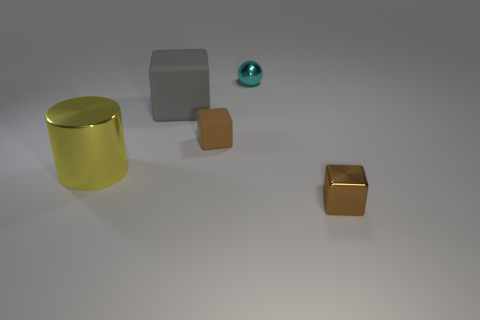Subtract all rubber cubes. How many cubes are left? 1 Add 3 cyan spheres. How many objects exist? 8 Subtract all gray blocks. How many blocks are left? 2 Subtract 1 cylinders. How many cylinders are left? 0 Subtract all balls. How many objects are left? 4 Subtract all blue cylinders. How many brown blocks are left? 2 Subtract all cyan cylinders. Subtract all gray cubes. How many cylinders are left? 1 Subtract all big blocks. Subtract all balls. How many objects are left? 3 Add 3 shiny balls. How many shiny balls are left? 4 Add 3 tiny metallic balls. How many tiny metallic balls exist? 4 